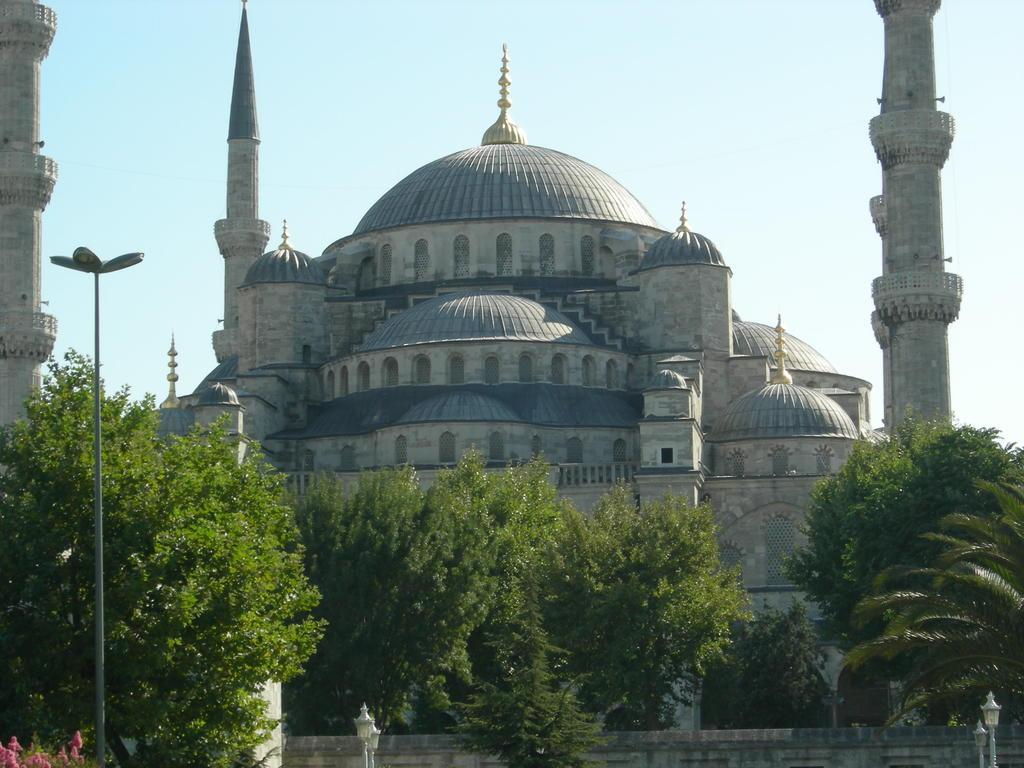What is the main structure in the center of the image? There is a building in the center of the image. What type of vegetation can be seen at the bottom of the image? Trees are visible at the bottom of the image. What other objects are present at the bottom of the image? Electric light poles and a wall are present at the bottom of the image. What type of flora is visible at the bottom of the image? Flowers are visible at the bottom of the image. What is visible at the top of the image? The sky is visible at the top of the image. What type of bell can be seen hanging from the building in the image? There is no bell present in the image; only the building, trees, electric light poles, wall, flowers, and sky are visible. 